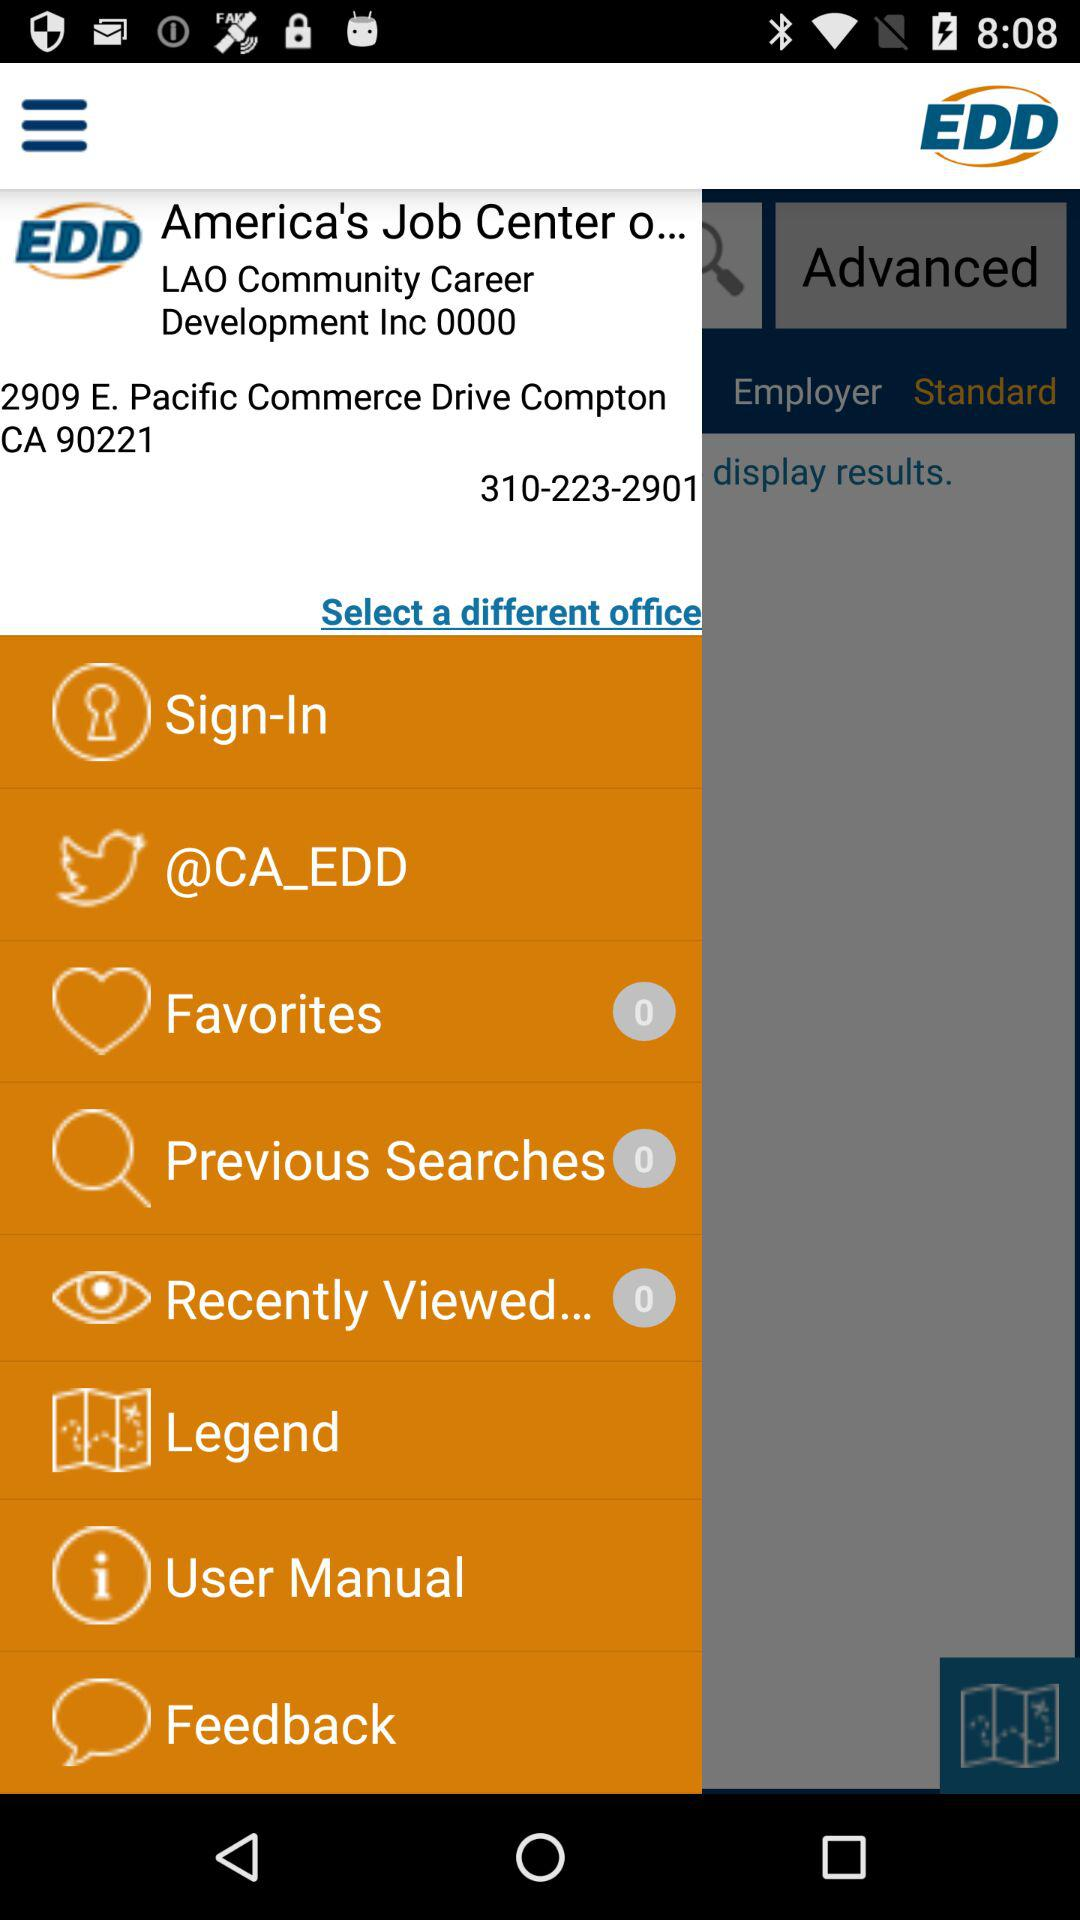Where is the location of the center? The location of the center is 2909 E. Pacific Commerce Drive Compton CA 90221. 